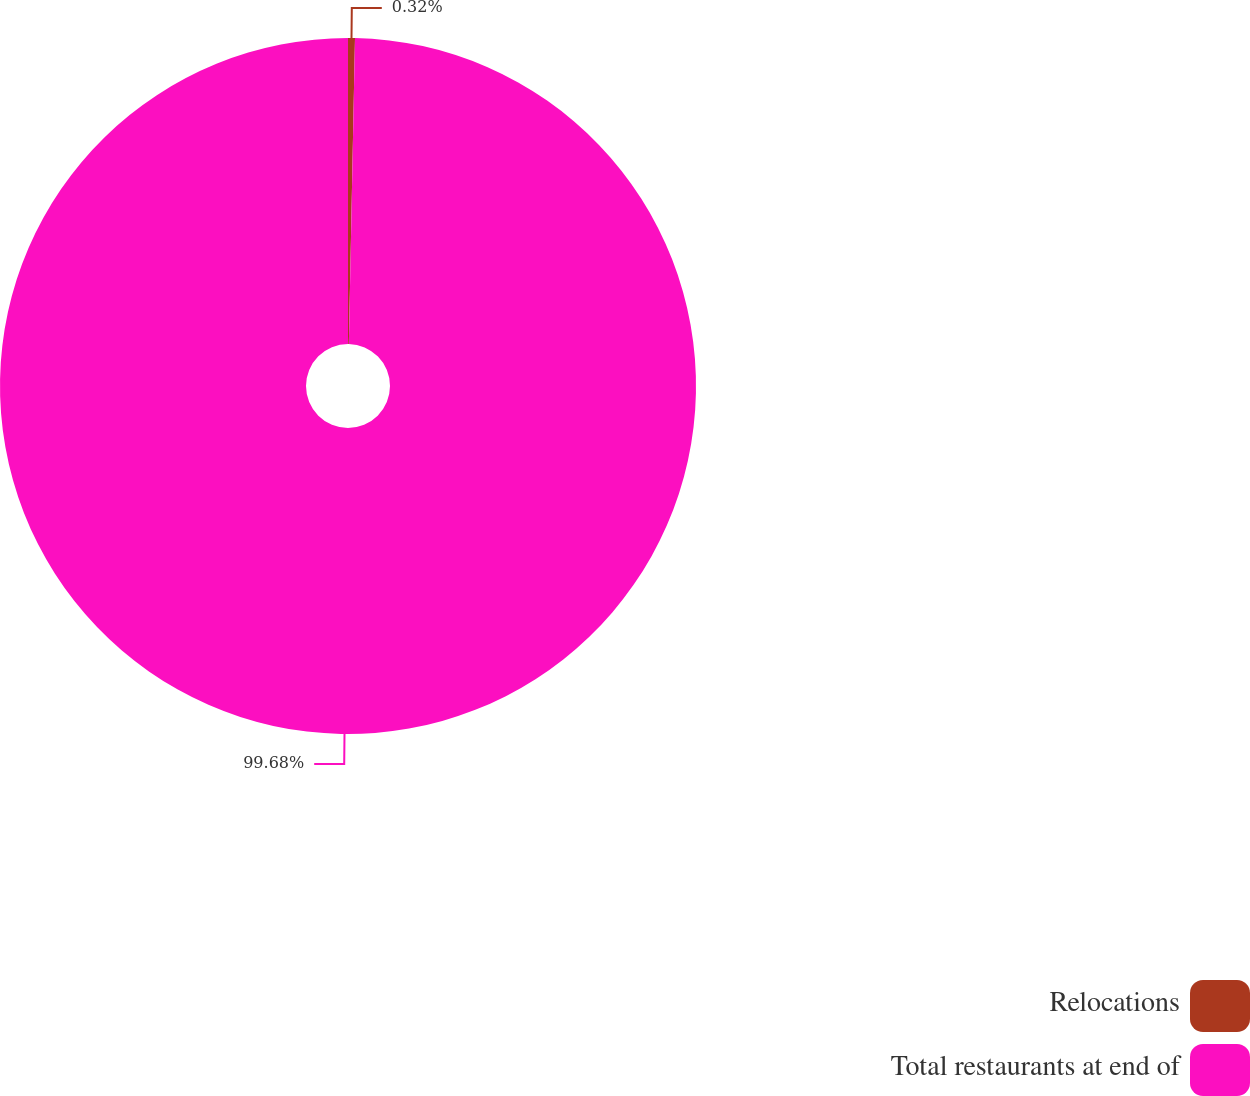Convert chart. <chart><loc_0><loc_0><loc_500><loc_500><pie_chart><fcel>Relocations<fcel>Total restaurants at end of<nl><fcel>0.32%<fcel>99.68%<nl></chart> 